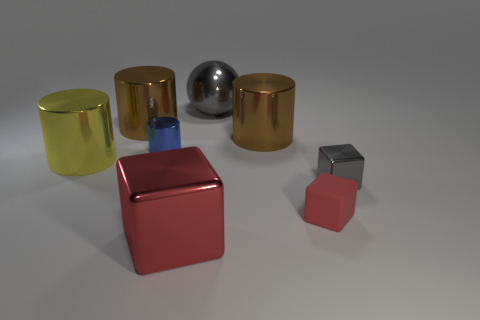Subtract all red blocks. How many blocks are left? 1 Subtract all red cubes. How many brown cylinders are left? 2 Subtract all blue cylinders. How many cylinders are left? 3 Add 1 green shiny blocks. How many objects exist? 9 Subtract all blocks. How many objects are left? 5 Subtract all purple cylinders. Subtract all blue balls. How many cylinders are left? 4 Add 3 yellow cylinders. How many yellow cylinders exist? 4 Subtract 1 blue cylinders. How many objects are left? 7 Subtract all small red metallic objects. Subtract all gray things. How many objects are left? 6 Add 3 blue metal things. How many blue metal things are left? 4 